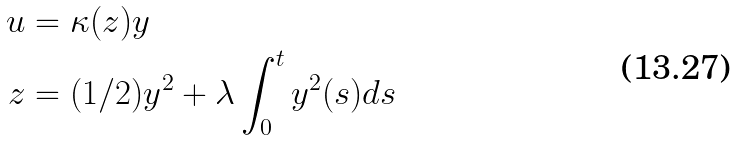Convert formula to latex. <formula><loc_0><loc_0><loc_500><loc_500>u & = \kappa ( z ) y \\ z & = ( 1 / 2 ) y ^ { 2 } + \lambda \int _ { 0 } ^ { t } { y ^ { 2 } ( s ) d s }</formula> 